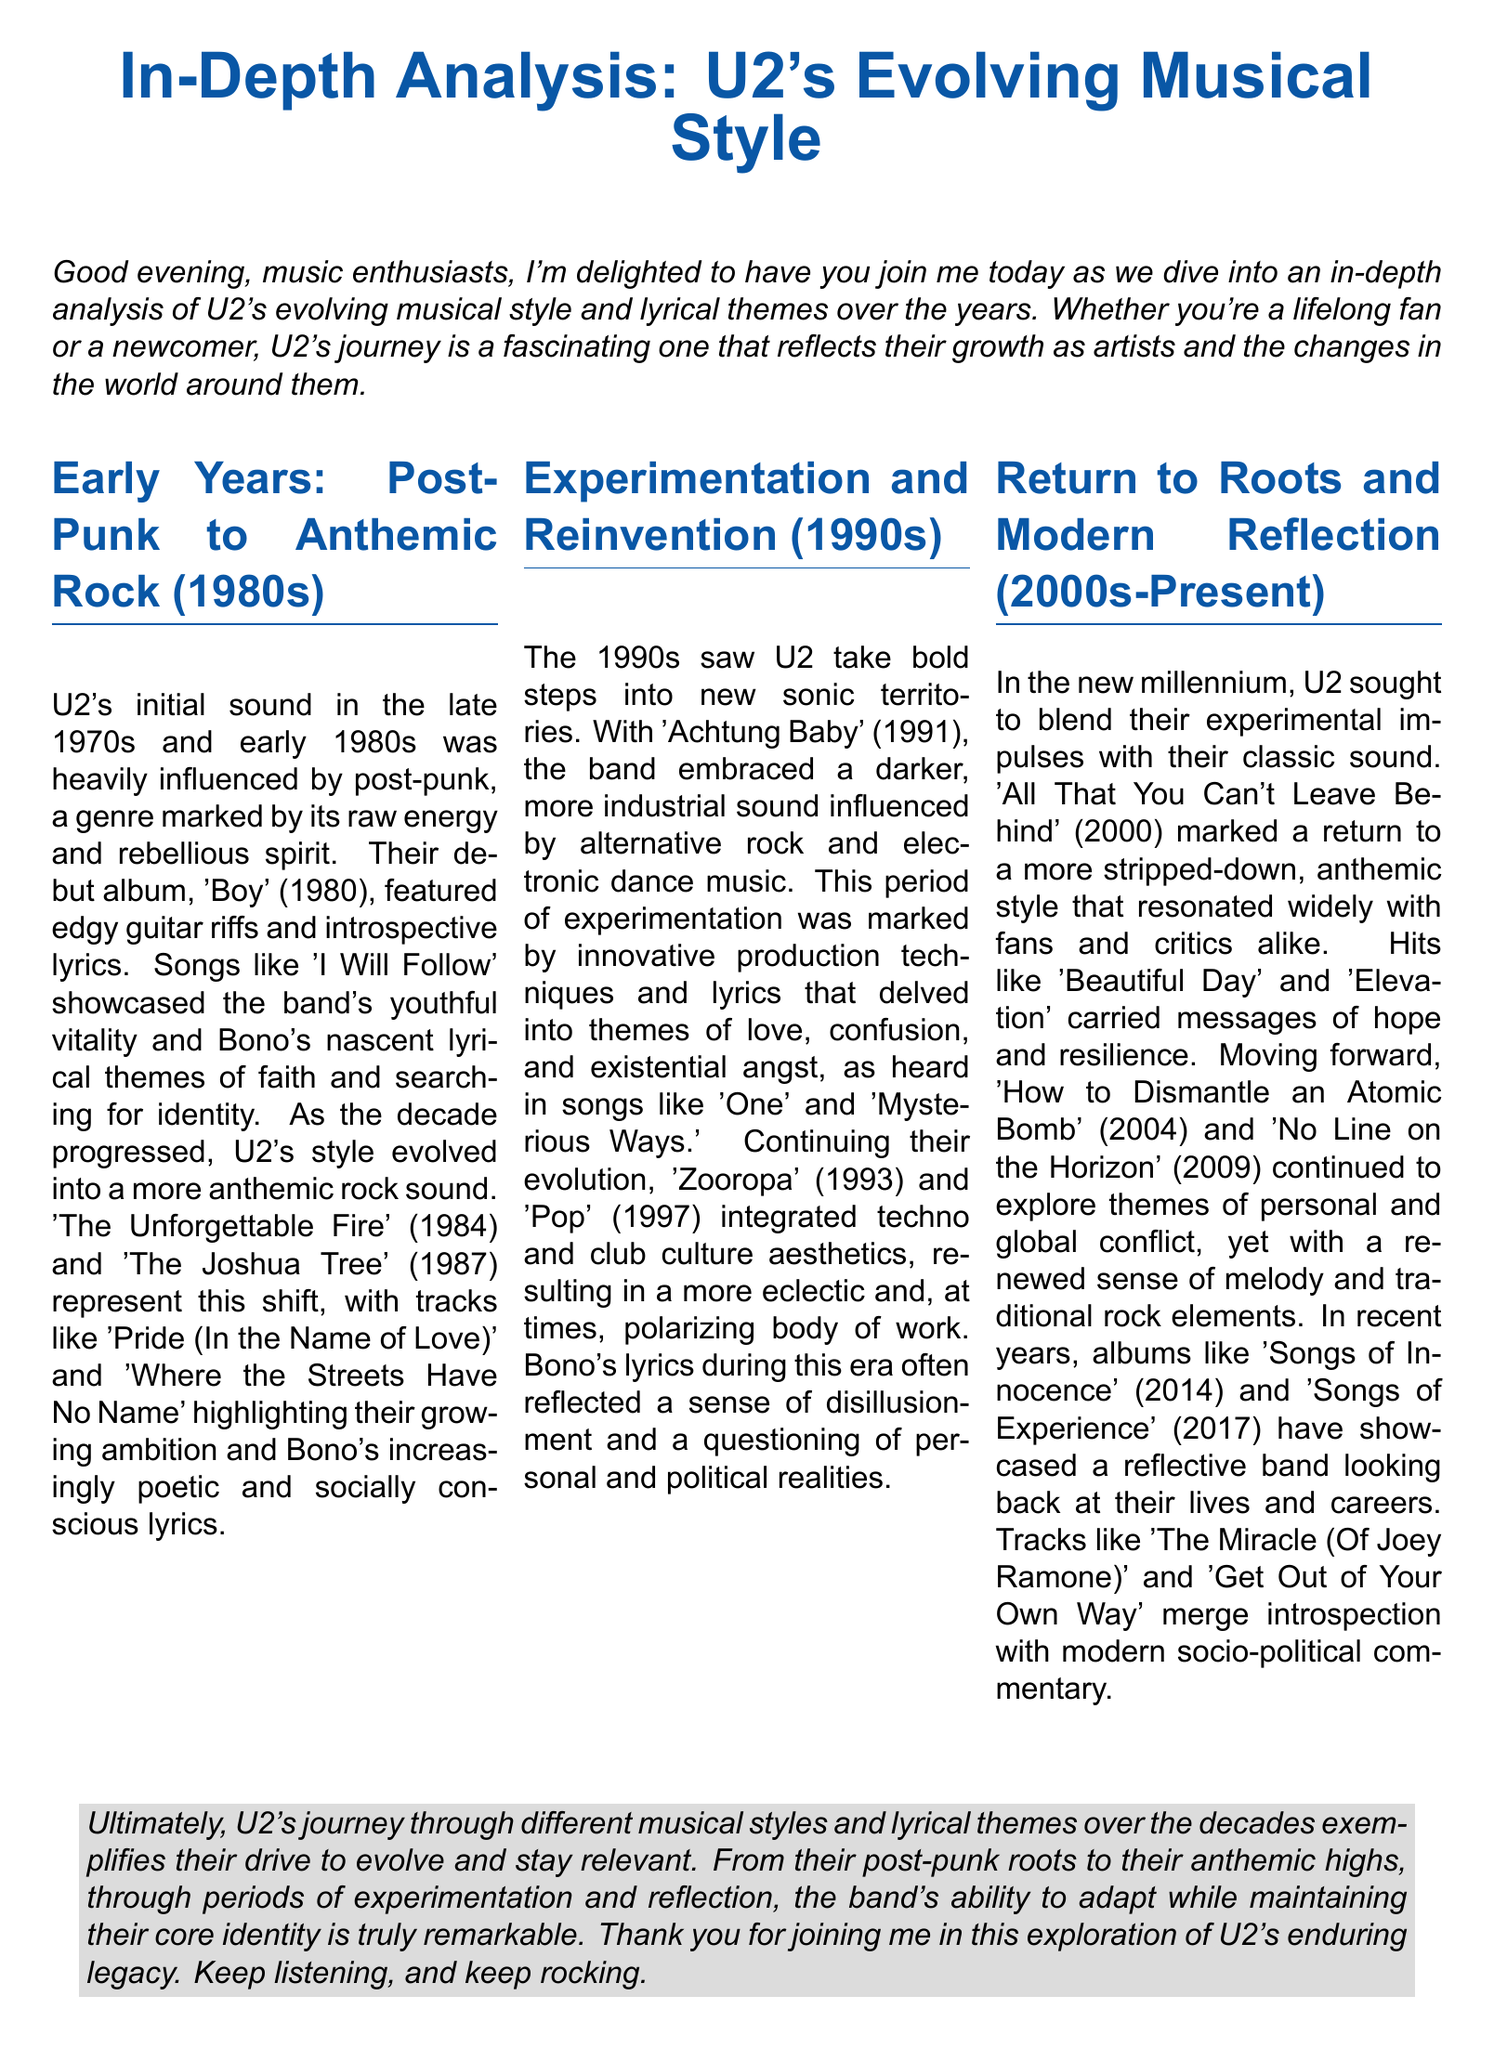What was U2's debut album? The document states that U2's debut album is 'Boy' released in 1980.
Answer: 'Boy' Which album marked U2's return to a stripped-down style? The document mentions 'All That You Can't Leave Behind' (2000) as the album marking the return to a more stripped-down style.
Answer: 'All That You Can't Leave Behind' What musical influences did U2 explore in the 1990s? The document states that U2 embraced a darker, more industrial sound and incorporated alternative rock and electronic dance music in the 1990s.
Answer: Alternative rock and electronic dance music What song is highlighted as showcasing U2's youthful vitality? The document identifies 'I Will Follow' as a song that showcases the band's youthful vitality in their early years.
Answer: 'I Will Follow' In which year did U2 release 'Achtung Baby'? According to the document, 'Achtung Baby' was released in 1991.
Answer: 1991 What type of themes do U2's lyrics generally reflect in the 2000s? The document states that U2's lyrics in the 2000s continue to explore themes of personal and global conflict.
Answer: Personal and global conflict How many years did the document cover in U2's history? The document discusses U2's journey over decades, specifically the 1980s, 1990s, and 2000s to present, covering at least 40 years.
Answer: 40 years Which song features the line "Get Out of Your Own Way"? The document mentions the song 'Get Out of Your Own Way' from their albums 'Songs of Innocence' (2014) and 'Songs of Experience' (2017).
Answer: 'Get Out of Your Own Way' What was the tone of U2's lyrics during the 1990s? The document describes the tone of U2's lyrics in the 1990s as reflecting a sense of disillusionment and a questioning of personal and political realities.
Answer: Disillusionment and questioning What is the main theme of U2's work according to the document? The document emphasizes U2's drive to evolve while maintaining their core identity.
Answer: Drive to evolve while maintaining core identity 